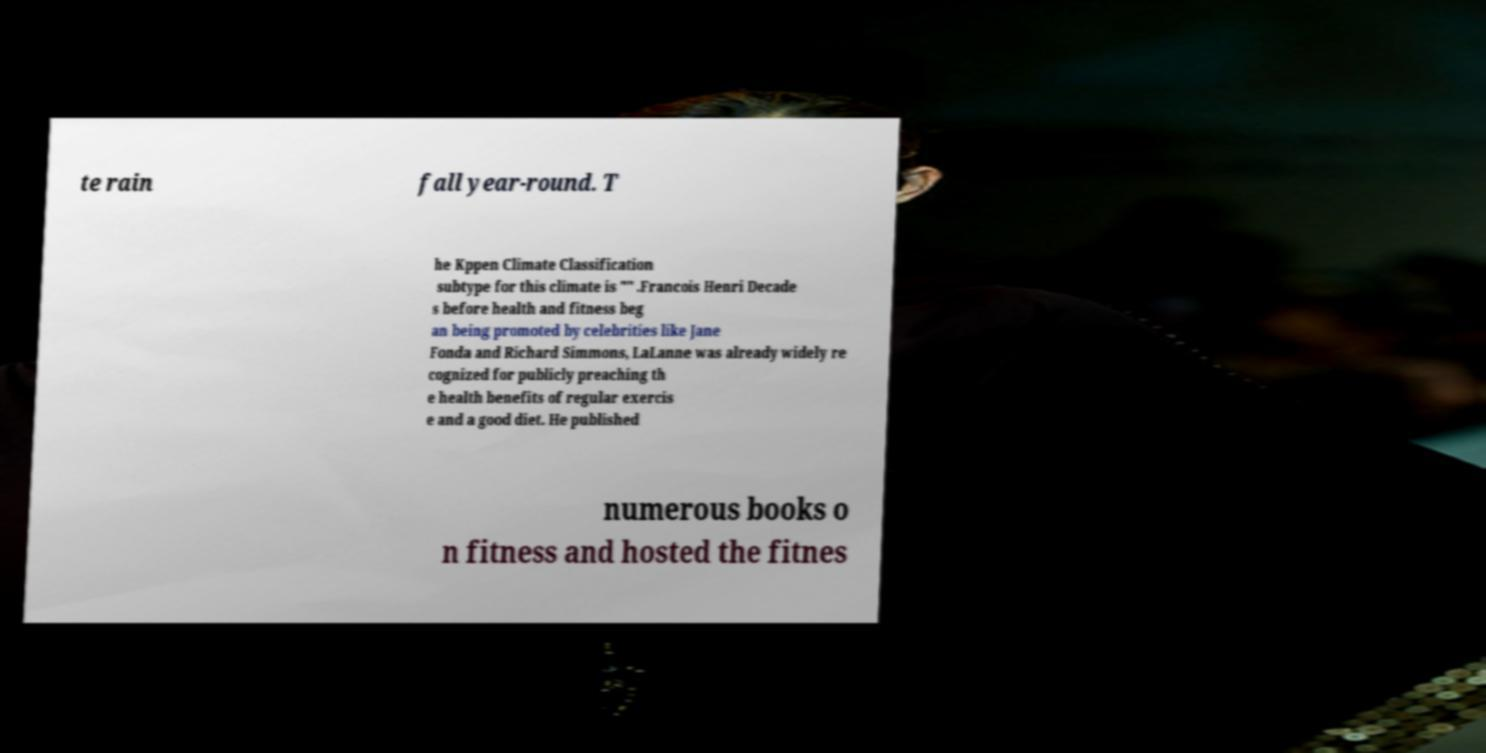I need the written content from this picture converted into text. Can you do that? te rain fall year-round. T he Kppen Climate Classification subtype for this climate is "" .Francois Henri Decade s before health and fitness beg an being promoted by celebrities like Jane Fonda and Richard Simmons, LaLanne was already widely re cognized for publicly preaching th e health benefits of regular exercis e and a good diet. He published numerous books o n fitness and hosted the fitnes 